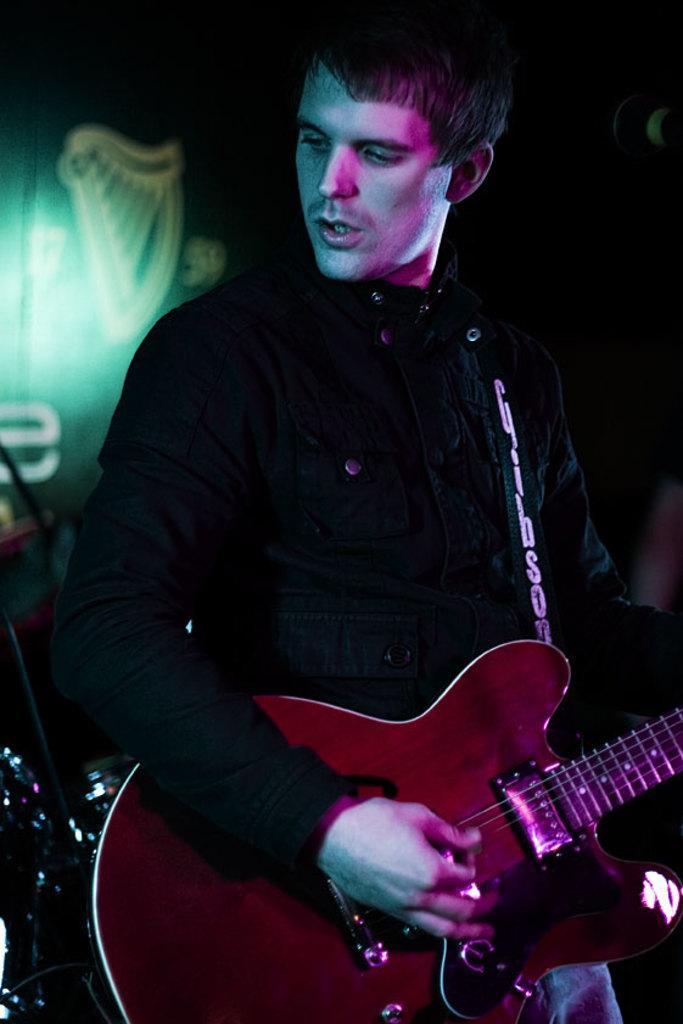In one or two sentences, can you explain what this image depicts? A man wearing a black jacket is playing a guitar. In the background there is a light. 